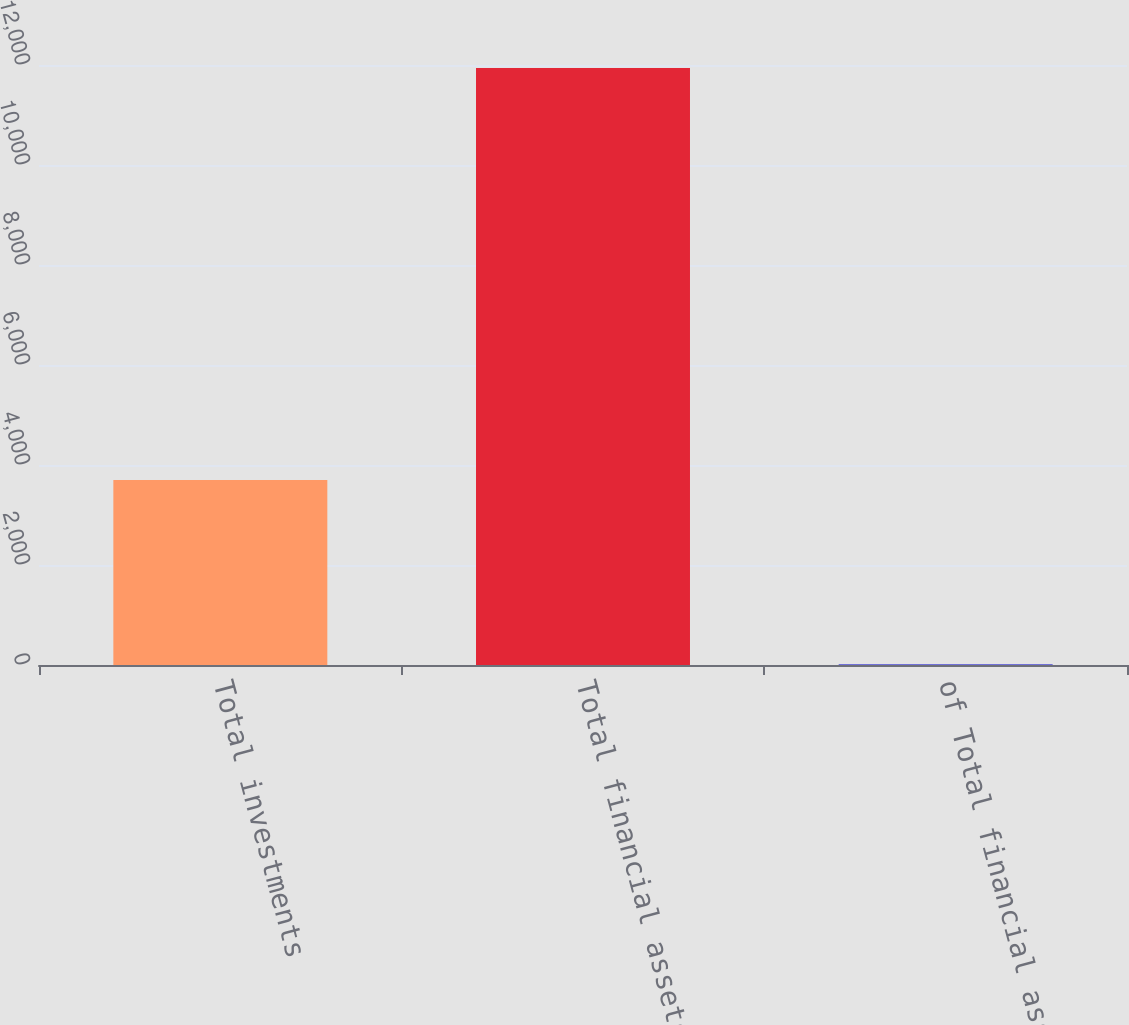<chart> <loc_0><loc_0><loc_500><loc_500><bar_chart><fcel>Total investments<fcel>Total financial assets<fcel>of Total financial assets<nl><fcel>3702<fcel>11941<fcel>11.4<nl></chart> 